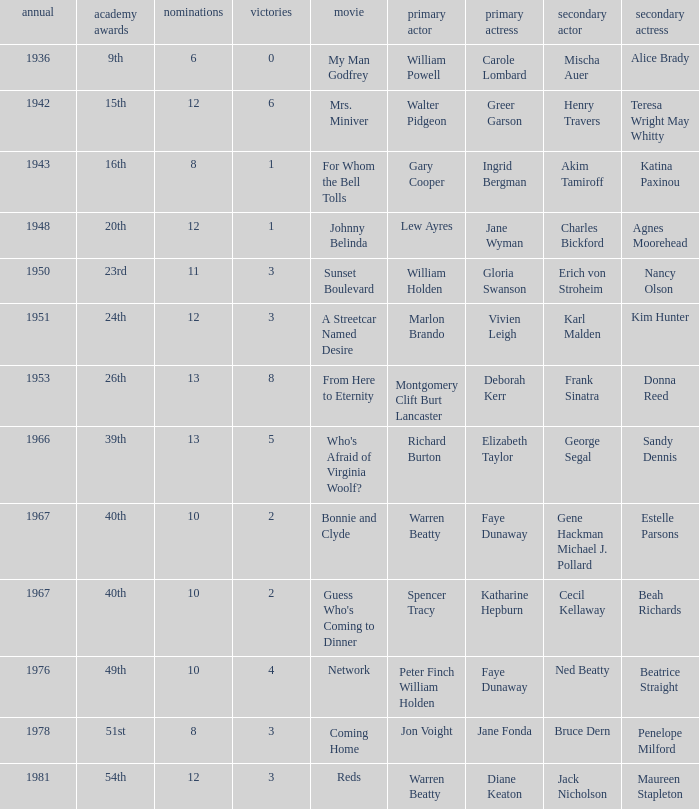Who was the leading actress in a film with Warren Beatty as the leading actor and also at the 40th Oscars? Faye Dunaway. 